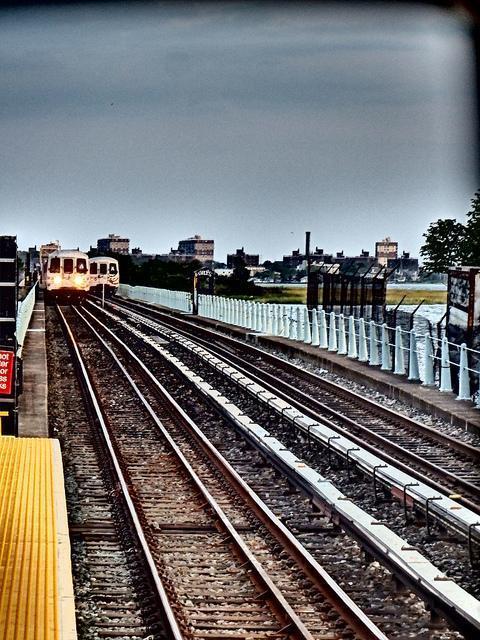How many train tracks are there?
Give a very brief answer. 2. How many people have on red?
Give a very brief answer. 0. 